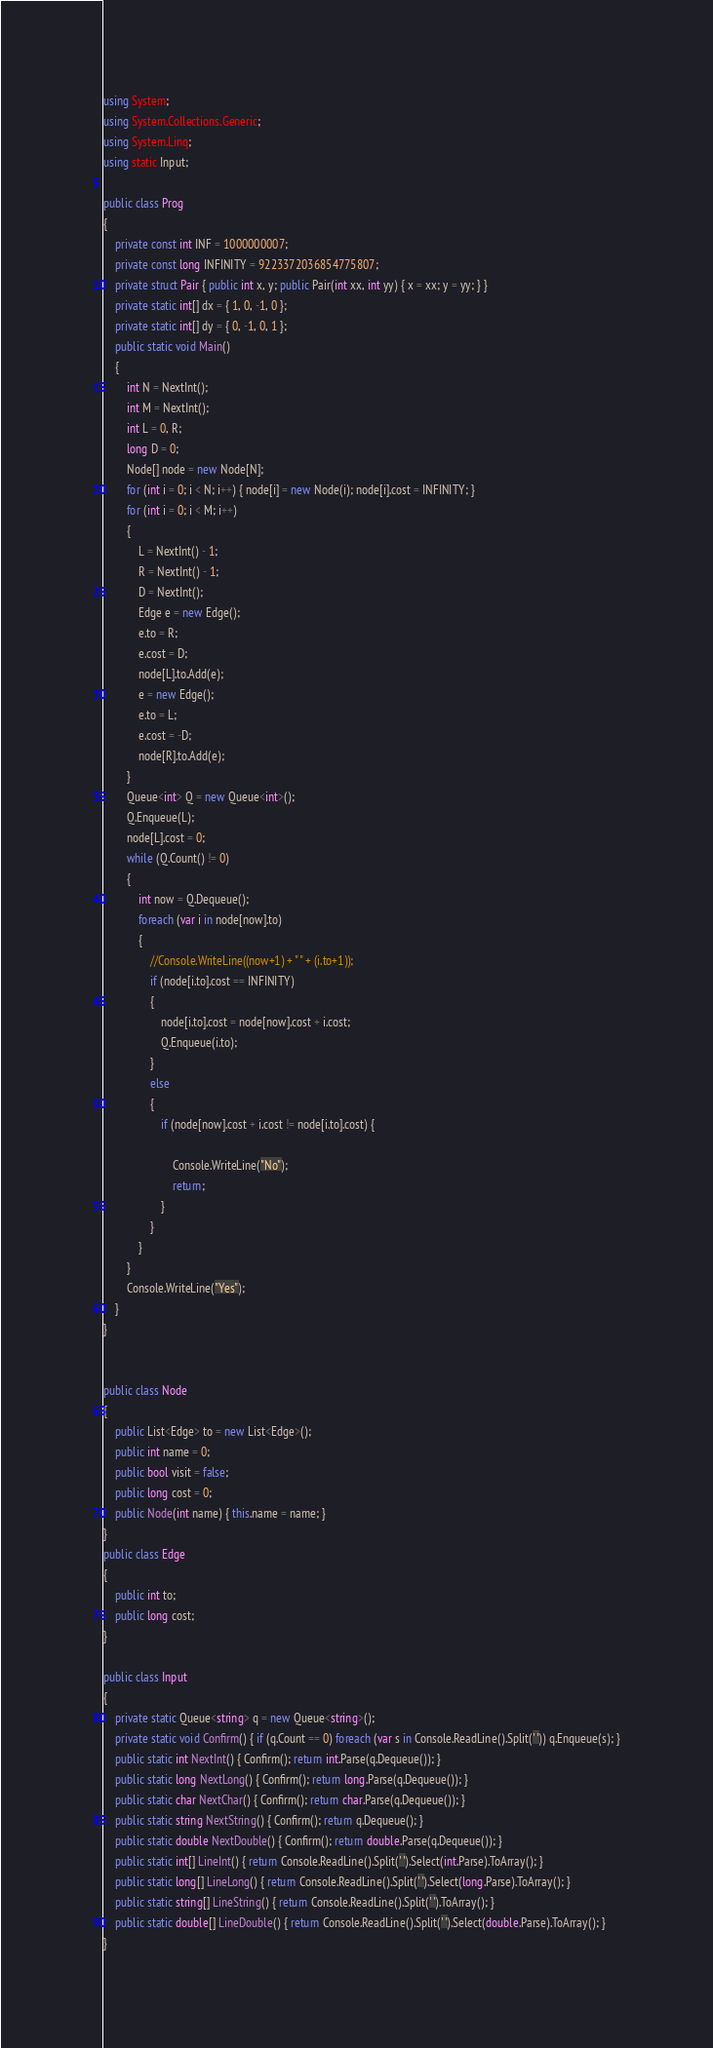Convert code to text. <code><loc_0><loc_0><loc_500><loc_500><_C#_>using System;
using System.Collections.Generic;
using System.Linq;
using static Input;

public class Prog
{
    private const int INF = 1000000007;
    private const long INFINITY = 9223372036854775807;
    private struct Pair { public int x, y; public Pair(int xx, int yy) { x = xx; y = yy; } }
    private static int[] dx = { 1, 0, -1, 0 };
    private static int[] dy = { 0, -1, 0, 1 };
    public static void Main()
    {
        int N = NextInt();
        int M = NextInt();
        int L = 0, R;
        long D = 0;
        Node[] node = new Node[N];
        for (int i = 0; i < N; i++) { node[i] = new Node(i); node[i].cost = INFINITY; }
        for (int i = 0; i < M; i++)
        {
            L = NextInt() - 1;
            R = NextInt() - 1;
            D = NextInt();
            Edge e = new Edge();
            e.to = R;
            e.cost = D;
            node[L].to.Add(e);
            e = new Edge();
            e.to = L;
            e.cost = -D;
            node[R].to.Add(e);
        }
        Queue<int> Q = new Queue<int>();
        Q.Enqueue(L);
        node[L].cost = 0;
        while (Q.Count() != 0)
        {
            int now = Q.Dequeue();
            foreach (var i in node[now].to)
            {
                //Console.WriteLine((now+1) + " " + (i.to+1));
                if (node[i.to].cost == INFINITY)
                {
                    node[i.to].cost = node[now].cost + i.cost;
                    Q.Enqueue(i.to);
                }
                else
                {
                    if (node[now].cost + i.cost != node[i.to].cost) {
                        
                        Console.WriteLine("No");
                        return;
                    }
                }
            }
        }
        Console.WriteLine("Yes");
    }
}


public class Node
{
    public List<Edge> to = new List<Edge>();
    public int name = 0;
    public bool visit = false;
    public long cost = 0;
    public Node(int name) { this.name = name; }
}
public class Edge
{
    public int to;
    public long cost;
}

public class Input
{
    private static Queue<string> q = new Queue<string>();
    private static void Confirm() { if (q.Count == 0) foreach (var s in Console.ReadLine().Split(' ')) q.Enqueue(s); }
    public static int NextInt() { Confirm(); return int.Parse(q.Dequeue()); }
    public static long NextLong() { Confirm(); return long.Parse(q.Dequeue()); }
    public static char NextChar() { Confirm(); return char.Parse(q.Dequeue()); }
    public static string NextString() { Confirm(); return q.Dequeue(); }
    public static double NextDouble() { Confirm(); return double.Parse(q.Dequeue()); }
    public static int[] LineInt() { return Console.ReadLine().Split(' ').Select(int.Parse).ToArray(); }
    public static long[] LineLong() { return Console.ReadLine().Split(' ').Select(long.Parse).ToArray(); }
    public static string[] LineString() { return Console.ReadLine().Split(' ').ToArray(); }
    public static double[] LineDouble() { return Console.ReadLine().Split(' ').Select(double.Parse).ToArray(); }
}
</code> 